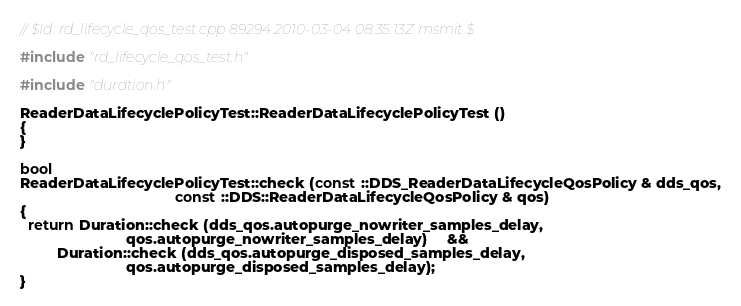Convert code to text. <code><loc_0><loc_0><loc_500><loc_500><_C++_>// $Id: rd_lifecycle_qos_test.cpp 89294 2010-03-04 08:35:13Z msmit $

#include "rd_lifecycle_qos_test.h"

#include "duration.h"

ReaderDataLifecyclePolicyTest::ReaderDataLifecyclePolicyTest ()
{
}

bool
ReaderDataLifecyclePolicyTest::check (const ::DDS_ReaderDataLifecycleQosPolicy & dds_qos,
                                      const ::DDS::ReaderDataLifecycleQosPolicy & qos)
{
  return Duration::check (dds_qos.autopurge_nowriter_samples_delay,
                          qos.autopurge_nowriter_samples_delay)     &&
         Duration::check (dds_qos.autopurge_disposed_samples_delay,
                          qos.autopurge_disposed_samples_delay);
}
</code> 